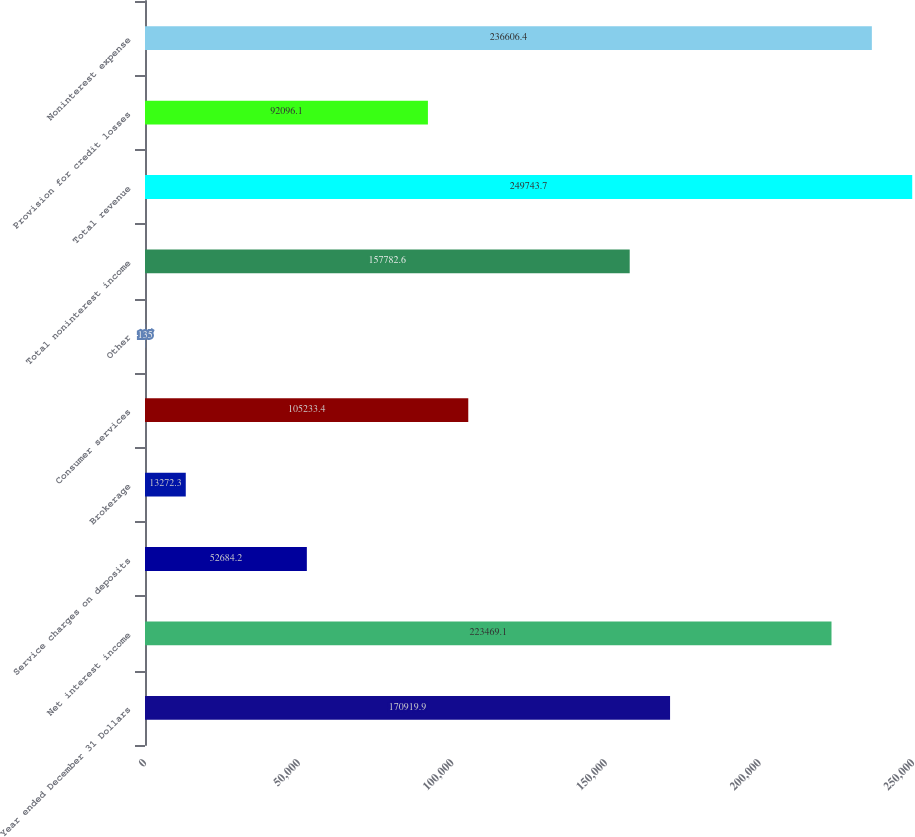Convert chart to OTSL. <chart><loc_0><loc_0><loc_500><loc_500><bar_chart><fcel>Year ended December 31 Dollars<fcel>Net interest income<fcel>Service charges on deposits<fcel>Brokerage<fcel>Consumer services<fcel>Other<fcel>Total noninterest income<fcel>Total revenue<fcel>Provision for credit losses<fcel>Noninterest expense<nl><fcel>170920<fcel>223469<fcel>52684.2<fcel>13272.3<fcel>105233<fcel>135<fcel>157783<fcel>249744<fcel>92096.1<fcel>236606<nl></chart> 